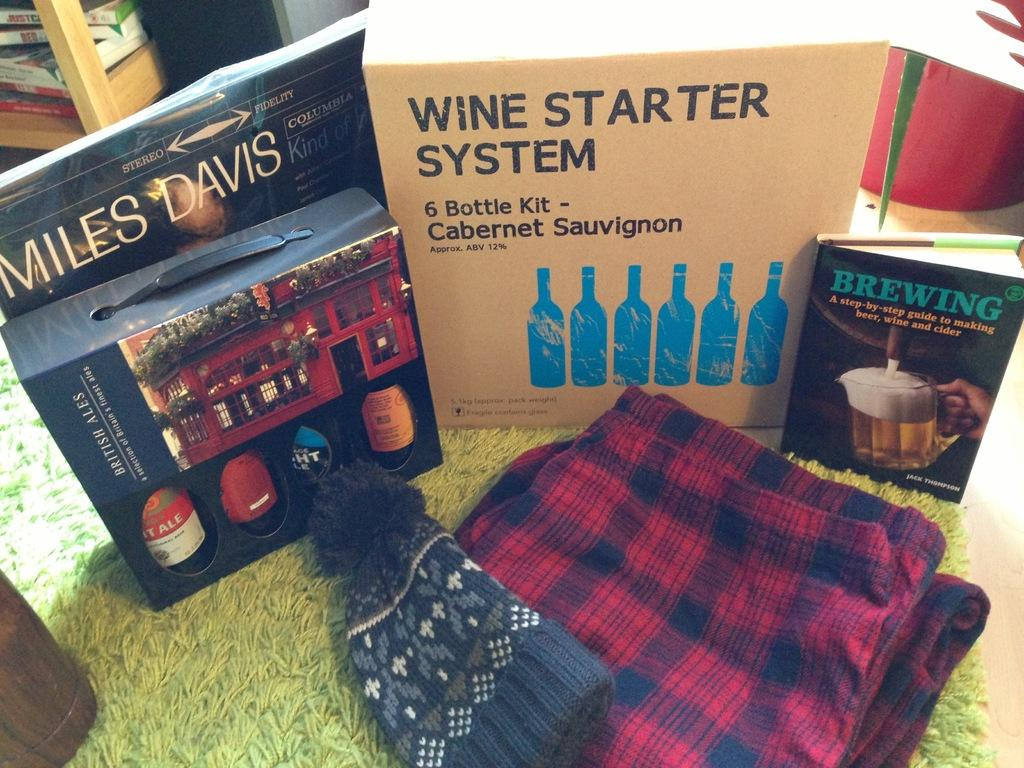<image>
Render a clear and concise summary of the photo. A bunch of unwrapped gifts on the ground incuding a wine starter system kit 